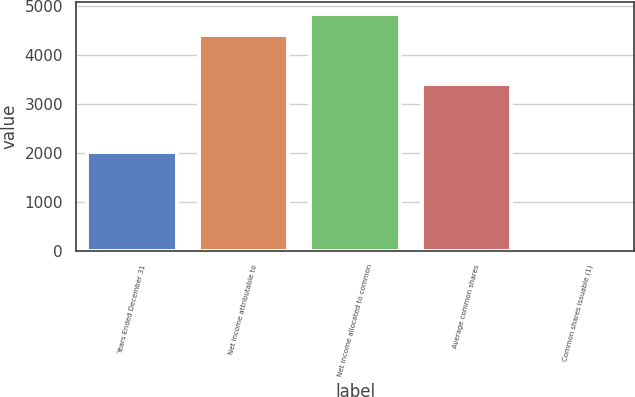Convert chart to OTSL. <chart><loc_0><loc_0><loc_500><loc_500><bar_chart><fcel>Years Ended December 31<fcel>Net income attributable to<fcel>Net income allocated to common<fcel>Average common shares<fcel>Common shares issuable (1)<nl><fcel>2013<fcel>4404<fcel>4841.1<fcel>3400.1<fcel>33<nl></chart> 